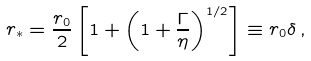Convert formula to latex. <formula><loc_0><loc_0><loc_500><loc_500>r _ { * } = \frac { r _ { 0 } } { 2 } \left [ 1 + \left ( 1 + \frac { \Gamma } { \eta } \right ) ^ { 1 / 2 } \right ] \equiv r _ { 0 } \delta \, ,</formula> 